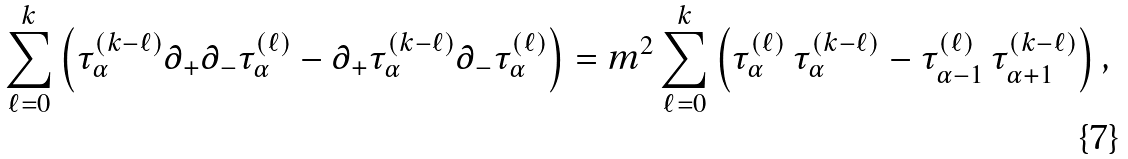<formula> <loc_0><loc_0><loc_500><loc_500>\sum _ { \ell = 0 } ^ { k } \left ( \tau _ { \alpha } ^ { ( k - \ell ) } \partial _ { + } \partial _ { - } \tau _ { \alpha } ^ { ( \ell ) } - \partial _ { + } \tau _ { \alpha } ^ { ( k - \ell ) } \partial _ { - } \tau _ { \alpha } ^ { ( \ell ) } \right ) = m ^ { 2 } \sum _ { \ell = 0 } ^ { k } \left ( \tau _ { \alpha } ^ { ( \ell ) } \, \tau _ { \alpha } ^ { ( k - \ell ) } - \tau _ { \alpha - 1 } ^ { ( \ell ) } \, \tau _ { \alpha + 1 } ^ { ( k - \ell ) } \right ) ,</formula> 